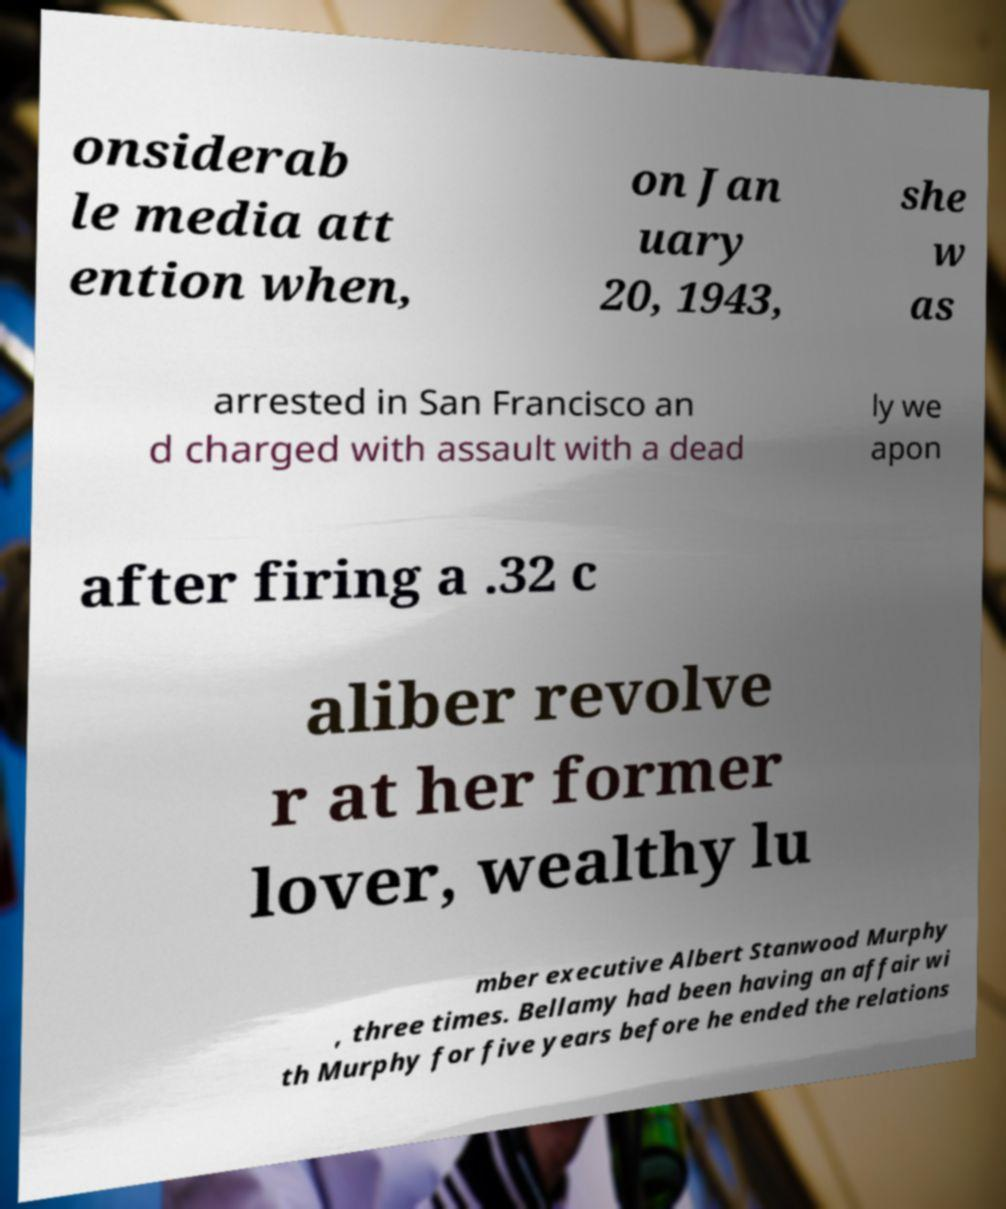What messages or text are displayed in this image? I need them in a readable, typed format. onsiderab le media att ention when, on Jan uary 20, 1943, she w as arrested in San Francisco an d charged with assault with a dead ly we apon after firing a .32 c aliber revolve r at her former lover, wealthy lu mber executive Albert Stanwood Murphy , three times. Bellamy had been having an affair wi th Murphy for five years before he ended the relations 